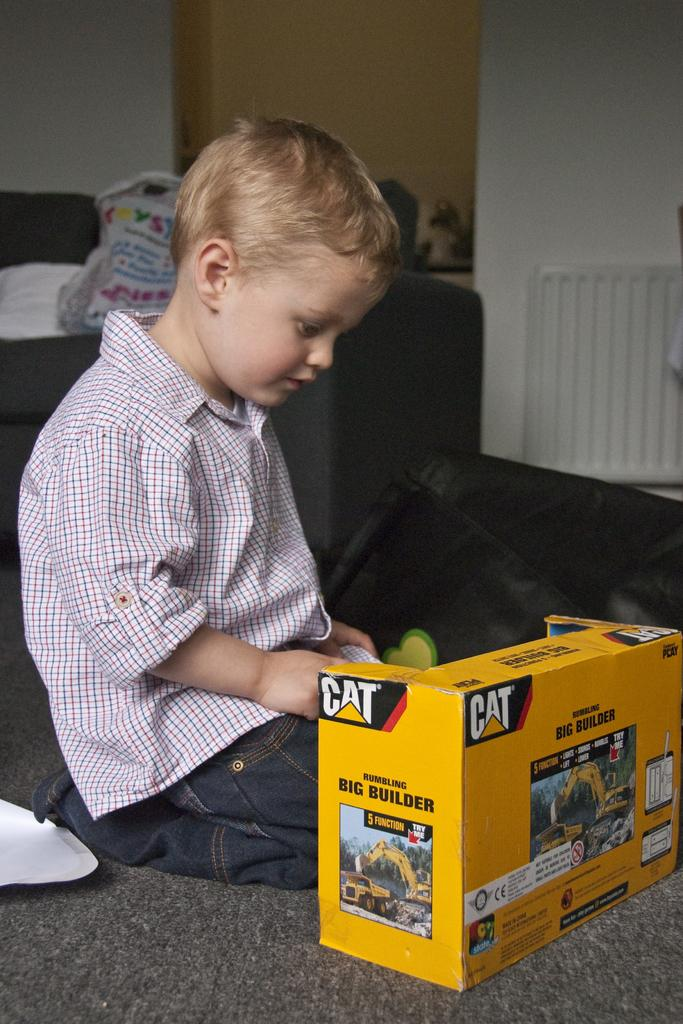<image>
Present a compact description of the photo's key features. A young boy looks at a CAT Big Builder toy in it's packaging. 